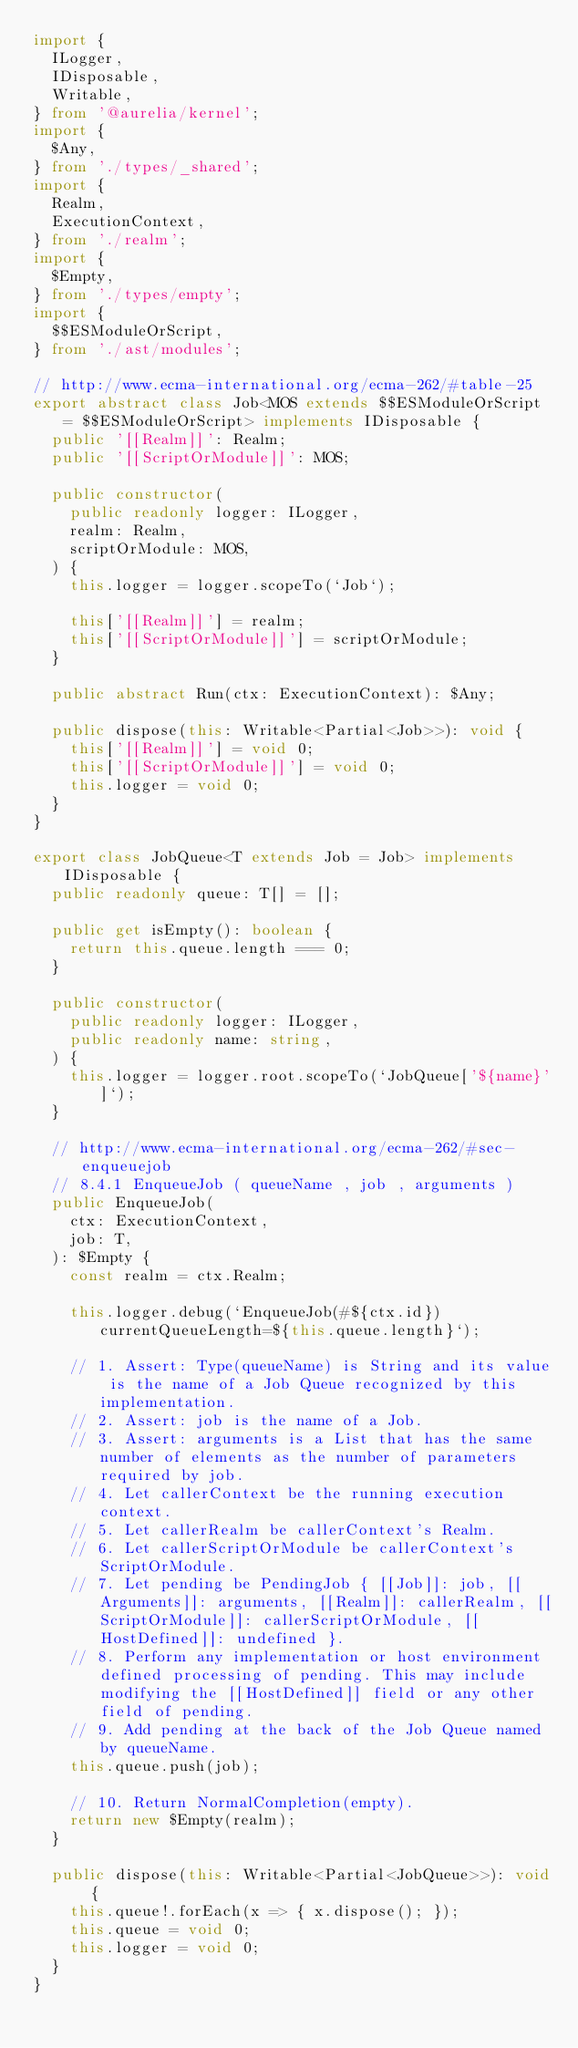Convert code to text. <code><loc_0><loc_0><loc_500><loc_500><_TypeScript_>import {
  ILogger,
  IDisposable,
  Writable,
} from '@aurelia/kernel';
import {
  $Any,
} from './types/_shared';
import {
  Realm,
  ExecutionContext,
} from './realm';
import {
  $Empty,
} from './types/empty';
import {
  $$ESModuleOrScript,
} from './ast/modules';

// http://www.ecma-international.org/ecma-262/#table-25
export abstract class Job<MOS extends $$ESModuleOrScript = $$ESModuleOrScript> implements IDisposable {
  public '[[Realm]]': Realm;
  public '[[ScriptOrModule]]': MOS;

  public constructor(
    public readonly logger: ILogger,
    realm: Realm,
    scriptOrModule: MOS,
  ) {
    this.logger = logger.scopeTo(`Job`);

    this['[[Realm]]'] = realm;
    this['[[ScriptOrModule]]'] = scriptOrModule;
  }

  public abstract Run(ctx: ExecutionContext): $Any;

  public dispose(this: Writable<Partial<Job>>): void {
    this['[[Realm]]'] = void 0;
    this['[[ScriptOrModule]]'] = void 0;
    this.logger = void 0;
  }
}

export class JobQueue<T extends Job = Job> implements IDisposable {
  public readonly queue: T[] = [];

  public get isEmpty(): boolean {
    return this.queue.length === 0;
  }

  public constructor(
    public readonly logger: ILogger,
    public readonly name: string,
  ) {
    this.logger = logger.root.scopeTo(`JobQueue['${name}']`);
  }

  // http://www.ecma-international.org/ecma-262/#sec-enqueuejob
  // 8.4.1 EnqueueJob ( queueName , job , arguments )
  public EnqueueJob(
    ctx: ExecutionContext,
    job: T,
  ): $Empty {
    const realm = ctx.Realm;

    this.logger.debug(`EnqueueJob(#${ctx.id}) currentQueueLength=${this.queue.length}`);

    // 1. Assert: Type(queueName) is String and its value is the name of a Job Queue recognized by this implementation.
    // 2. Assert: job is the name of a Job.
    // 3. Assert: arguments is a List that has the same number of elements as the number of parameters required by job.
    // 4. Let callerContext be the running execution context.
    // 5. Let callerRealm be callerContext's Realm.
    // 6. Let callerScriptOrModule be callerContext's ScriptOrModule.
    // 7. Let pending be PendingJob { [[Job]]: job, [[Arguments]]: arguments, [[Realm]]: callerRealm, [[ScriptOrModule]]: callerScriptOrModule, [[HostDefined]]: undefined }.
    // 8. Perform any implementation or host environment defined processing of pending. This may include modifying the [[HostDefined]] field or any other field of pending.
    // 9. Add pending at the back of the Job Queue named by queueName.
    this.queue.push(job);

    // 10. Return NormalCompletion(empty).
    return new $Empty(realm);
  }

  public dispose(this: Writable<Partial<JobQueue>>): void {
    this.queue!.forEach(x => { x.dispose(); });
    this.queue = void 0;
    this.logger = void 0;
  }
}
</code> 